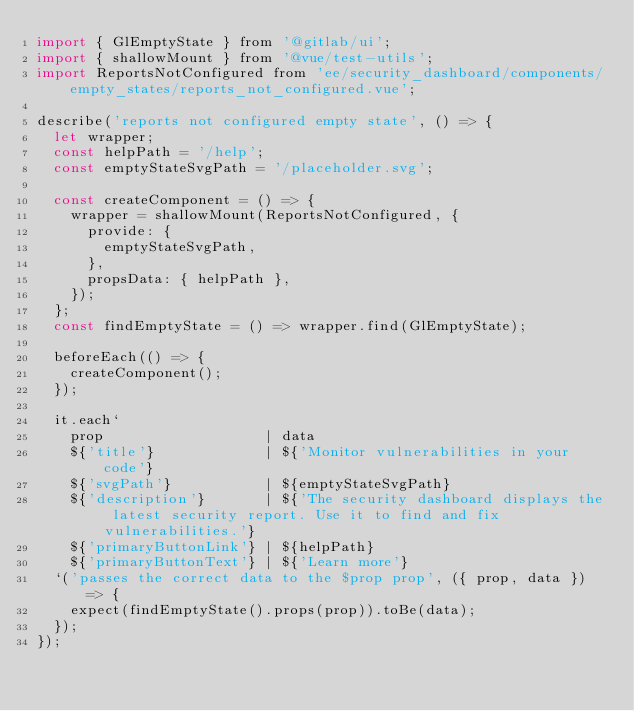<code> <loc_0><loc_0><loc_500><loc_500><_JavaScript_>import { GlEmptyState } from '@gitlab/ui';
import { shallowMount } from '@vue/test-utils';
import ReportsNotConfigured from 'ee/security_dashboard/components/empty_states/reports_not_configured.vue';

describe('reports not configured empty state', () => {
  let wrapper;
  const helpPath = '/help';
  const emptyStateSvgPath = '/placeholder.svg';

  const createComponent = () => {
    wrapper = shallowMount(ReportsNotConfigured, {
      provide: {
        emptyStateSvgPath,
      },
      propsData: { helpPath },
    });
  };
  const findEmptyState = () => wrapper.find(GlEmptyState);

  beforeEach(() => {
    createComponent();
  });

  it.each`
    prop                   | data
    ${'title'}             | ${'Monitor vulnerabilities in your code'}
    ${'svgPath'}           | ${emptyStateSvgPath}
    ${'description'}       | ${'The security dashboard displays the latest security report. Use it to find and fix vulnerabilities.'}
    ${'primaryButtonLink'} | ${helpPath}
    ${'primaryButtonText'} | ${'Learn more'}
  `('passes the correct data to the $prop prop', ({ prop, data }) => {
    expect(findEmptyState().props(prop)).toBe(data);
  });
});
</code> 